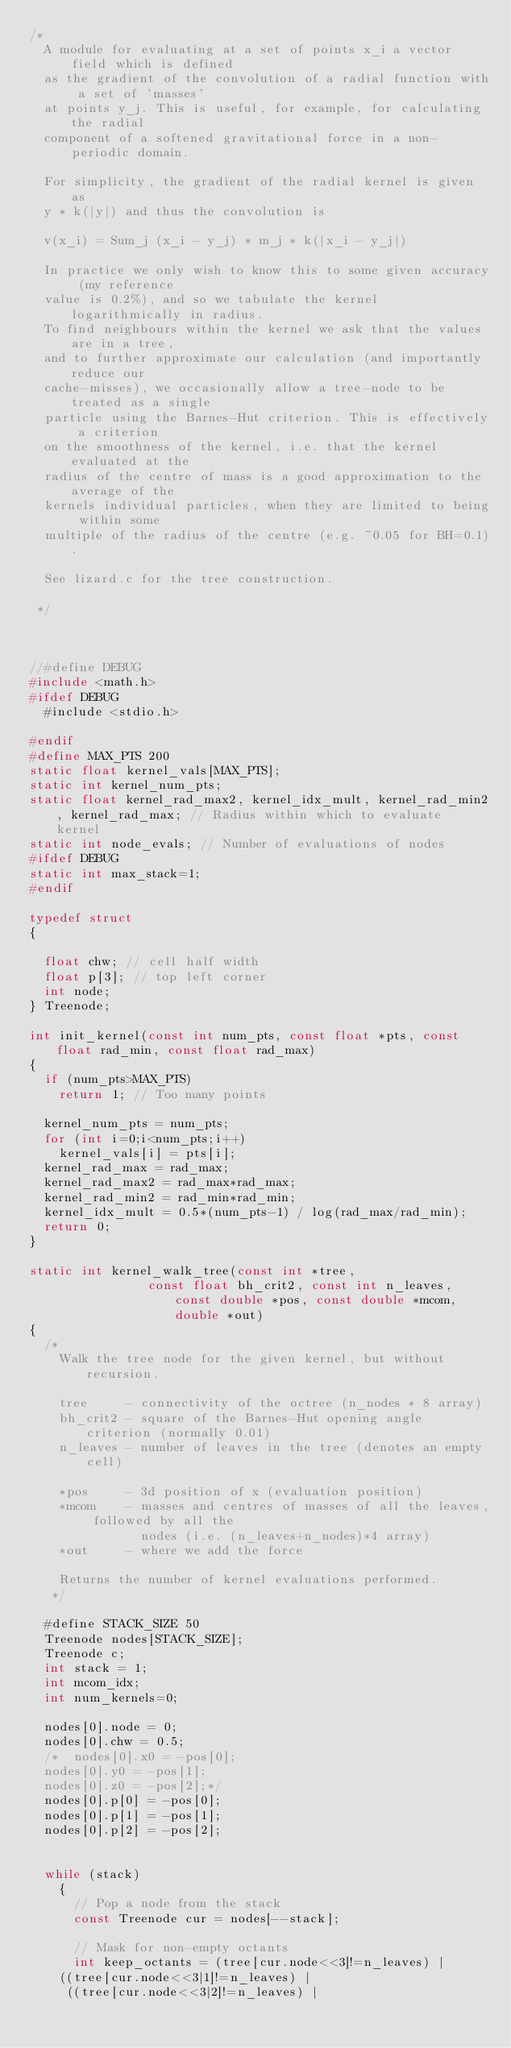Convert code to text. <code><loc_0><loc_0><loc_500><loc_500><_C_>/*
  A module for evaluating at a set of points x_i a vector field which is defined
  as the gradient of the convolution of a radial function with a set of 'masses'
  at points y_j. This is useful, for example, for calculating the radial 
  component of a softened gravitational force in a non-periodic domain.

  For simplicity, the gradient of the radial kernel is given as
  y * k(|y|) and thus the convolution is 

  v(x_i) = Sum_j (x_i - y_j) * m_j * k(|x_i - y_j|)

  In practice we only wish to know this to some given accuracy (my reference
  value is 0.2%), and so we tabulate the kernel logarithmically in radius.
  To find neighbours within the kernel we ask that the values are in a tree, 
  and to further approximate our calculation (and importantly reduce our 
  cache-misses), we occasionally allow a tree-node to be treated as a single 
  particle using the Barnes-Hut criterion. This is effectively a criterion
  on the smoothness of the kernel, i.e. that the kernel evaluated at the 
  radius of the centre of mass is a good approximation to the average of the
  kernels individual particles, when they are limited to being within some 
  multiple of the radius of the centre (e.g. ~0.05 for BH=0.1).
  
  See lizard.c for the tree construction.

 */



//#define DEBUG
#include <math.h>
#ifdef DEBUG
  #include <stdio.h>

#endif
#define MAX_PTS 200
static float kernel_vals[MAX_PTS];
static int kernel_num_pts;
static float kernel_rad_max2, kernel_idx_mult, kernel_rad_min2, kernel_rad_max; // Radius within which to evaluate kernel
static int node_evals; // Number of evaluations of nodes
#ifdef DEBUG
static int max_stack=1;
#endif

typedef struct
{

  float chw; // cell half width
  float p[3]; // top left corner
  int node;
} Treenode;

int init_kernel(const int num_pts, const float *pts, const float rad_min, const float rad_max)
{
  if (num_pts>MAX_PTS)
    return 1; // Too many points

  kernel_num_pts = num_pts;
  for (int i=0;i<num_pts;i++)
    kernel_vals[i] = pts[i];
  kernel_rad_max = rad_max;
  kernel_rad_max2 = rad_max*rad_max;
  kernel_rad_min2 = rad_min*rad_min;
  kernel_idx_mult = 0.5*(num_pts-1) / log(rad_max/rad_min);
  return 0;
}

static int kernel_walk_tree(const int *tree, 
			    const float bh_crit2, const int n_leaves, const double *pos, const double *mcom, double *out)
{
  /*
    Walk the tree node for the given kernel, but without recursion.

    tree     - connectivity of the octree (n_nodes * 8 array)
    bh_crit2 - square of the Barnes-Hut opening angle criterion (normally 0.01)
    n_leaves - number of leaves in the tree (denotes an empty cell)
    
    *pos     - 3d position of x (evaluation position)
    *mcom    - masses and centres of masses of all the leaves, followed by all the
               nodes (i.e. (n_leaves+n_nodes)*4 array)
    *out     - where we add the force

    Returns the number of kernel evaluations performed.
   */

  #define STACK_SIZE 50
  Treenode nodes[STACK_SIZE];
  Treenode c;
  int stack = 1;
  int mcom_idx;
  int num_kernels=0;

  nodes[0].node = 0;
  nodes[0].chw = 0.5;
  /*  nodes[0].x0 = -pos[0];
  nodes[0].y0 = -pos[1];
  nodes[0].z0 = -pos[2];*/
  nodes[0].p[0] = -pos[0];
  nodes[0].p[1] = -pos[1];
  nodes[0].p[2] = -pos[2];

  
  while (stack)
    {
      // Pop a node from the stack
      const Treenode cur = nodes[--stack];

      // Mask for non-empty octants
      int keep_octants = (tree[cur.node<<3]!=n_leaves) | 
	((tree[cur.node<<3|1]!=n_leaves) | 
	 ((tree[cur.node<<3|2]!=n_leaves) | </code> 